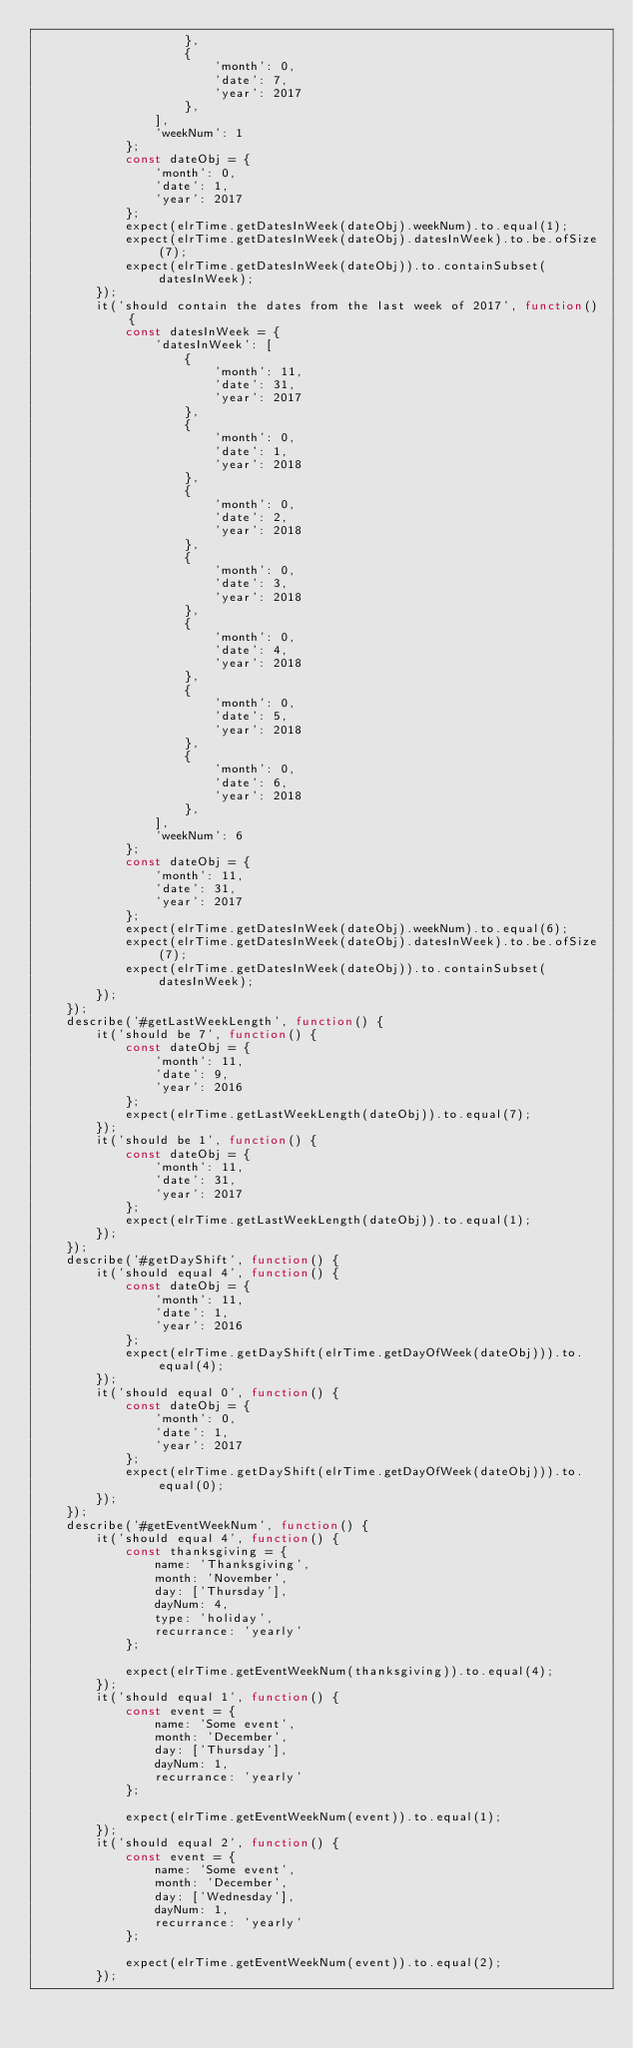<code> <loc_0><loc_0><loc_500><loc_500><_JavaScript_>                    },
                    {
                        'month': 0,
                        'date': 7,
                        'year': 2017
                    },
                ],
                'weekNum': 1
            };
            const dateObj = {
                'month': 0,
                'date': 1,
                'year': 2017
            };
            expect(elrTime.getDatesInWeek(dateObj).weekNum).to.equal(1);
            expect(elrTime.getDatesInWeek(dateObj).datesInWeek).to.be.ofSize(7);
            expect(elrTime.getDatesInWeek(dateObj)).to.containSubset(datesInWeek);
        });
        it('should contain the dates from the last week of 2017', function() {
            const datesInWeek = {
                'datesInWeek': [
                    {
                        'month': 11,
                        'date': 31,
                        'year': 2017
                    },
                    {
                        'month': 0,
                        'date': 1,
                        'year': 2018
                    },
                    {
                        'month': 0,
                        'date': 2,
                        'year': 2018
                    },
                    {
                        'month': 0,
                        'date': 3,
                        'year': 2018
                    },
                    {
                        'month': 0,
                        'date': 4,
                        'year': 2018
                    },
                    {
                        'month': 0,
                        'date': 5,
                        'year': 2018
                    },
                    {
                        'month': 0,
                        'date': 6,
                        'year': 2018
                    },
                ],
                'weekNum': 6
            };
            const dateObj = {
                'month': 11,
                'date': 31,
                'year': 2017
            };
            expect(elrTime.getDatesInWeek(dateObj).weekNum).to.equal(6);
            expect(elrTime.getDatesInWeek(dateObj).datesInWeek).to.be.ofSize(7);
            expect(elrTime.getDatesInWeek(dateObj)).to.containSubset(datesInWeek);
        });
    });
    describe('#getLastWeekLength', function() {
        it('should be 7', function() {
            const dateObj = {
                'month': 11,
                'date': 9,
                'year': 2016
            };
            expect(elrTime.getLastWeekLength(dateObj)).to.equal(7);
        });
        it('should be 1', function() {
            const dateObj = {
                'month': 11,
                'date': 31,
                'year': 2017
            };
            expect(elrTime.getLastWeekLength(dateObj)).to.equal(1);
        });
    });
    describe('#getDayShift', function() {
        it('should equal 4', function() {
            const dateObj = {
                'month': 11,
                'date': 1,
                'year': 2016
            };
            expect(elrTime.getDayShift(elrTime.getDayOfWeek(dateObj))).to.equal(4);
        });
        it('should equal 0', function() {
            const dateObj = {
                'month': 0,
                'date': 1,
                'year': 2017
            };
            expect(elrTime.getDayShift(elrTime.getDayOfWeek(dateObj))).to.equal(0);
        });
    });
    describe('#getEventWeekNum', function() {
        it('should equal 4', function() {
            const thanksgiving = {
                name: 'Thanksgiving',
                month: 'November',
                day: ['Thursday'],
                dayNum: 4,
                type: 'holiday',
                recurrance: 'yearly'
            };

            expect(elrTime.getEventWeekNum(thanksgiving)).to.equal(4);
        });
        it('should equal 1', function() {
            const event = {
                name: 'Some event',
                month: 'December',
                day: ['Thursday'],
                dayNum: 1,
                recurrance: 'yearly'
            };

            expect(elrTime.getEventWeekNum(event)).to.equal(1);
        });
        it('should equal 2', function() {
            const event = {
                name: 'Some event',
                month: 'December',
                day: ['Wednesday'],
                dayNum: 1,
                recurrance: 'yearly'
            };

            expect(elrTime.getEventWeekNum(event)).to.equal(2);
        });</code> 